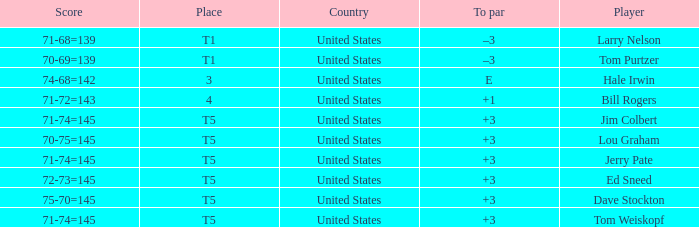What country is player ed sneed, who has a to par of +3, from? United States. 